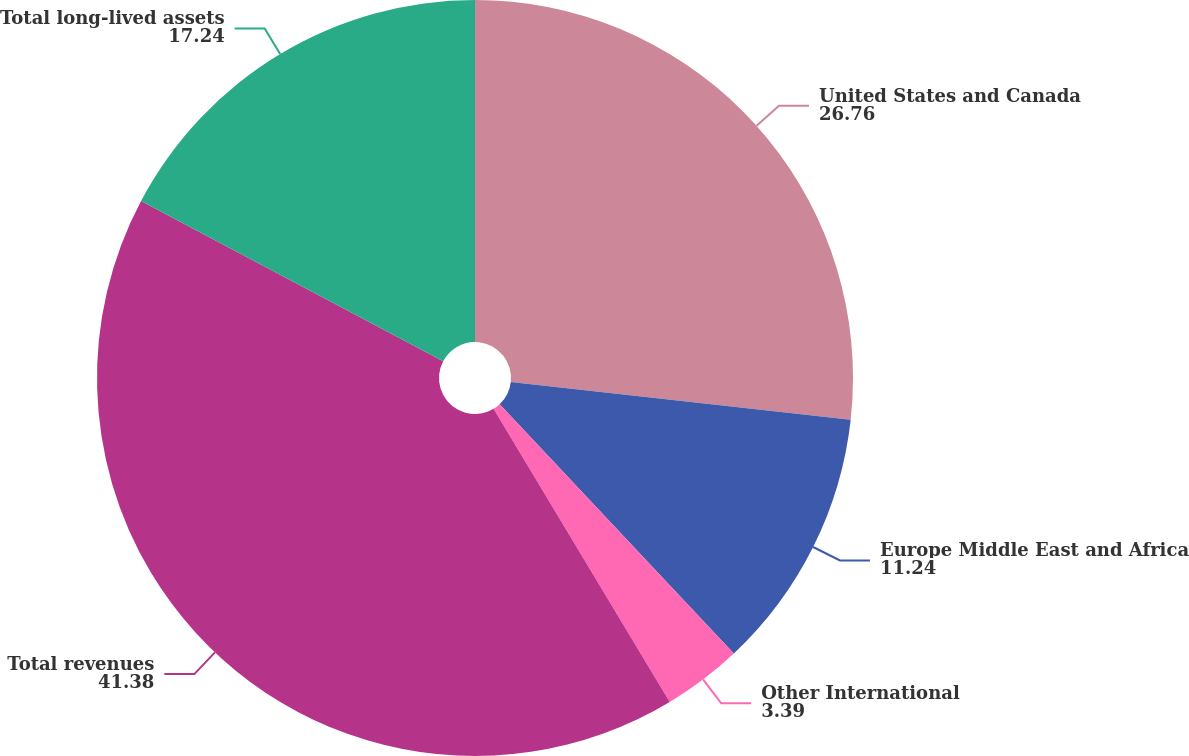Convert chart to OTSL. <chart><loc_0><loc_0><loc_500><loc_500><pie_chart><fcel>United States and Canada<fcel>Europe Middle East and Africa<fcel>Other International<fcel>Total revenues<fcel>Total long-lived assets<nl><fcel>26.76%<fcel>11.24%<fcel>3.39%<fcel>41.38%<fcel>17.24%<nl></chart> 